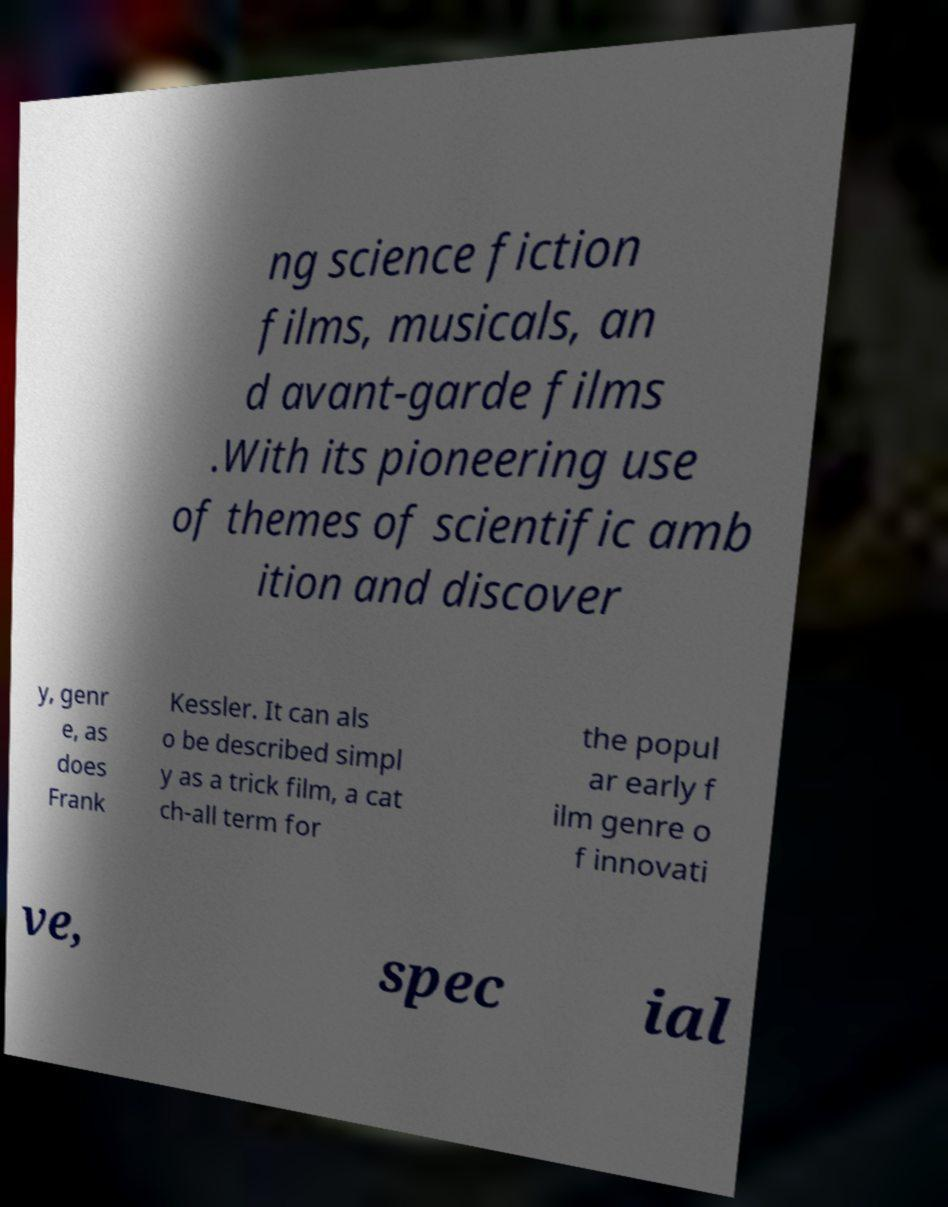Could you assist in decoding the text presented in this image and type it out clearly? ng science fiction films, musicals, an d avant-garde films .With its pioneering use of themes of scientific amb ition and discover y, genr e, as does Frank Kessler. It can als o be described simpl y as a trick film, a cat ch-all term for the popul ar early f ilm genre o f innovati ve, spec ial 